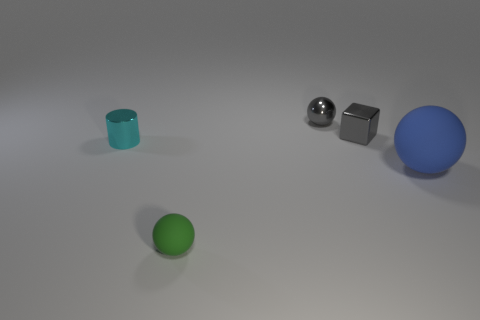Subtract all brown balls. Subtract all blue cylinders. How many balls are left? 3 Add 3 yellow cubes. How many objects exist? 8 Subtract all cylinders. How many objects are left? 4 Subtract 0 yellow cylinders. How many objects are left? 5 Subtract all tiny gray things. Subtract all cyan cylinders. How many objects are left? 2 Add 4 big things. How many big things are left? 5 Add 4 tiny green matte balls. How many tiny green matte balls exist? 5 